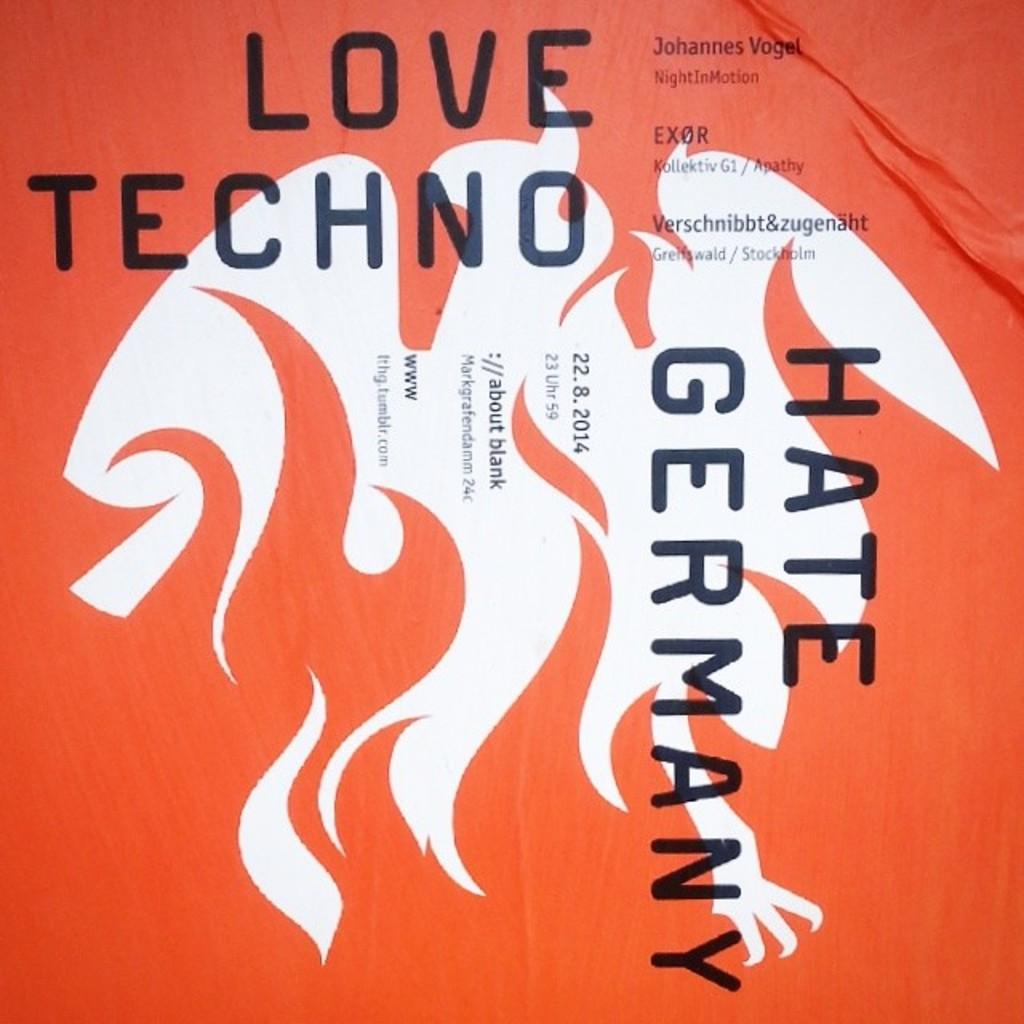<image>
Share a concise interpretation of the image provided. A book with an orange cover called Hate Germany. 